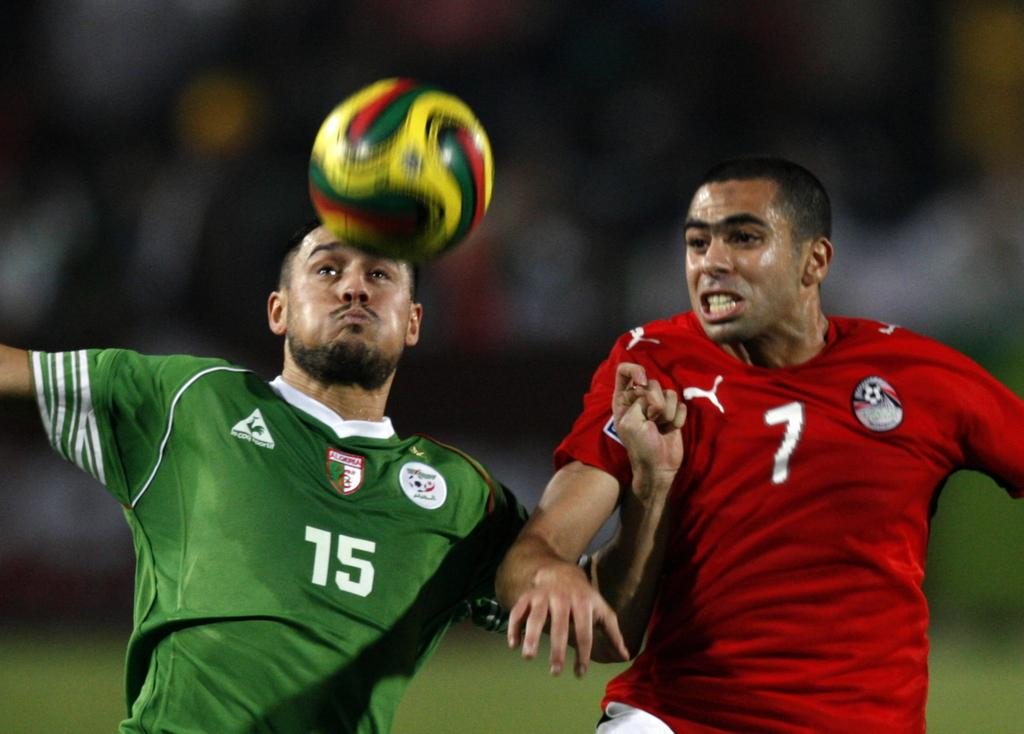How many men are in the image? There are two men in the image. What colors are the t-shirts of the men? One man is wearing a green t-shirt, and the other man is wearing a red t-shirt. What activity are the men engaged in? Both men are playing football. What type of surface is visible in the background of the image? There is grass in the background of the image. Can you describe any other elements in the background of the image? There are other unspecified items in the background of the image. What type of kite is the man with the green t-shirt flying in the image? There is no kite present in the image; the men are playing football. How did the man with the red t-shirt sustain a wound during the game? There is no mention of a wound in the image; both men appear to be playing football without any visible injuries. 